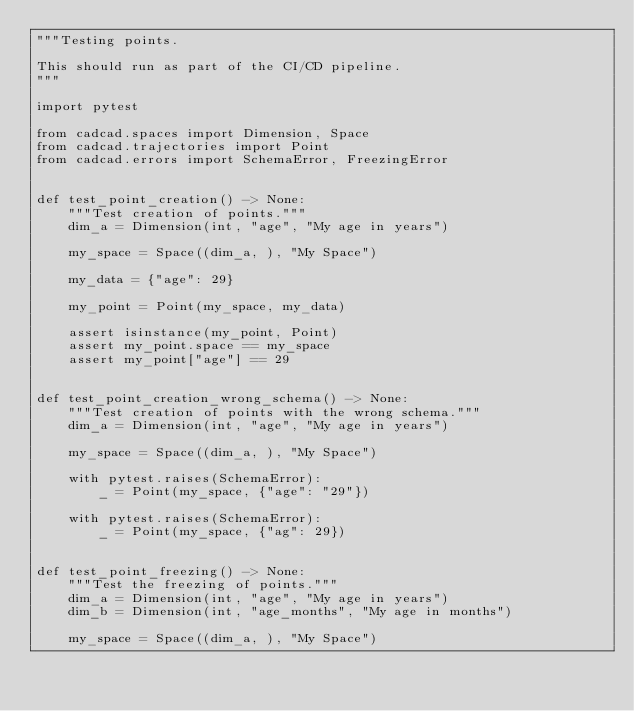<code> <loc_0><loc_0><loc_500><loc_500><_Python_>"""Testing points.

This should run as part of the CI/CD pipeline.
"""

import pytest

from cadcad.spaces import Dimension, Space
from cadcad.trajectories import Point
from cadcad.errors import SchemaError, FreezingError


def test_point_creation() -> None:
    """Test creation of points."""
    dim_a = Dimension(int, "age", "My age in years")

    my_space = Space((dim_a, ), "My Space")

    my_data = {"age": 29}

    my_point = Point(my_space, my_data)

    assert isinstance(my_point, Point)
    assert my_point.space == my_space
    assert my_point["age"] == 29


def test_point_creation_wrong_schema() -> None:
    """Test creation of points with the wrong schema."""
    dim_a = Dimension(int, "age", "My age in years")

    my_space = Space((dim_a, ), "My Space")

    with pytest.raises(SchemaError):
        _ = Point(my_space, {"age": "29"})

    with pytest.raises(SchemaError):
        _ = Point(my_space, {"ag": 29})


def test_point_freezing() -> None:
    """Test the freezing of points."""
    dim_a = Dimension(int, "age", "My age in years")
    dim_b = Dimension(int, "age_months", "My age in months")

    my_space = Space((dim_a, ), "My Space")</code> 